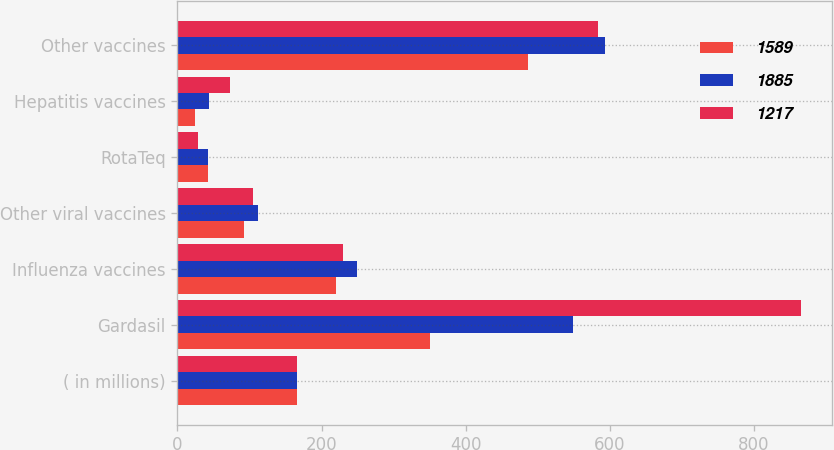Convert chart to OTSL. <chart><loc_0><loc_0><loc_500><loc_500><stacked_bar_chart><ecel><fcel>( in millions)<fcel>Gardasil<fcel>Influenza vaccines<fcel>Other viral vaccines<fcel>RotaTeq<fcel>Hepatitis vaccines<fcel>Other vaccines<nl><fcel>1589<fcel>166<fcel>350<fcel>220<fcel>93<fcel>42<fcel>25<fcel>487<nl><fcel>1885<fcel>166<fcel>549<fcel>249<fcel>112<fcel>42<fcel>44<fcel>593<nl><fcel>1217<fcel>166<fcel>865<fcel>230<fcel>105<fcel>28<fcel>73<fcel>584<nl></chart> 